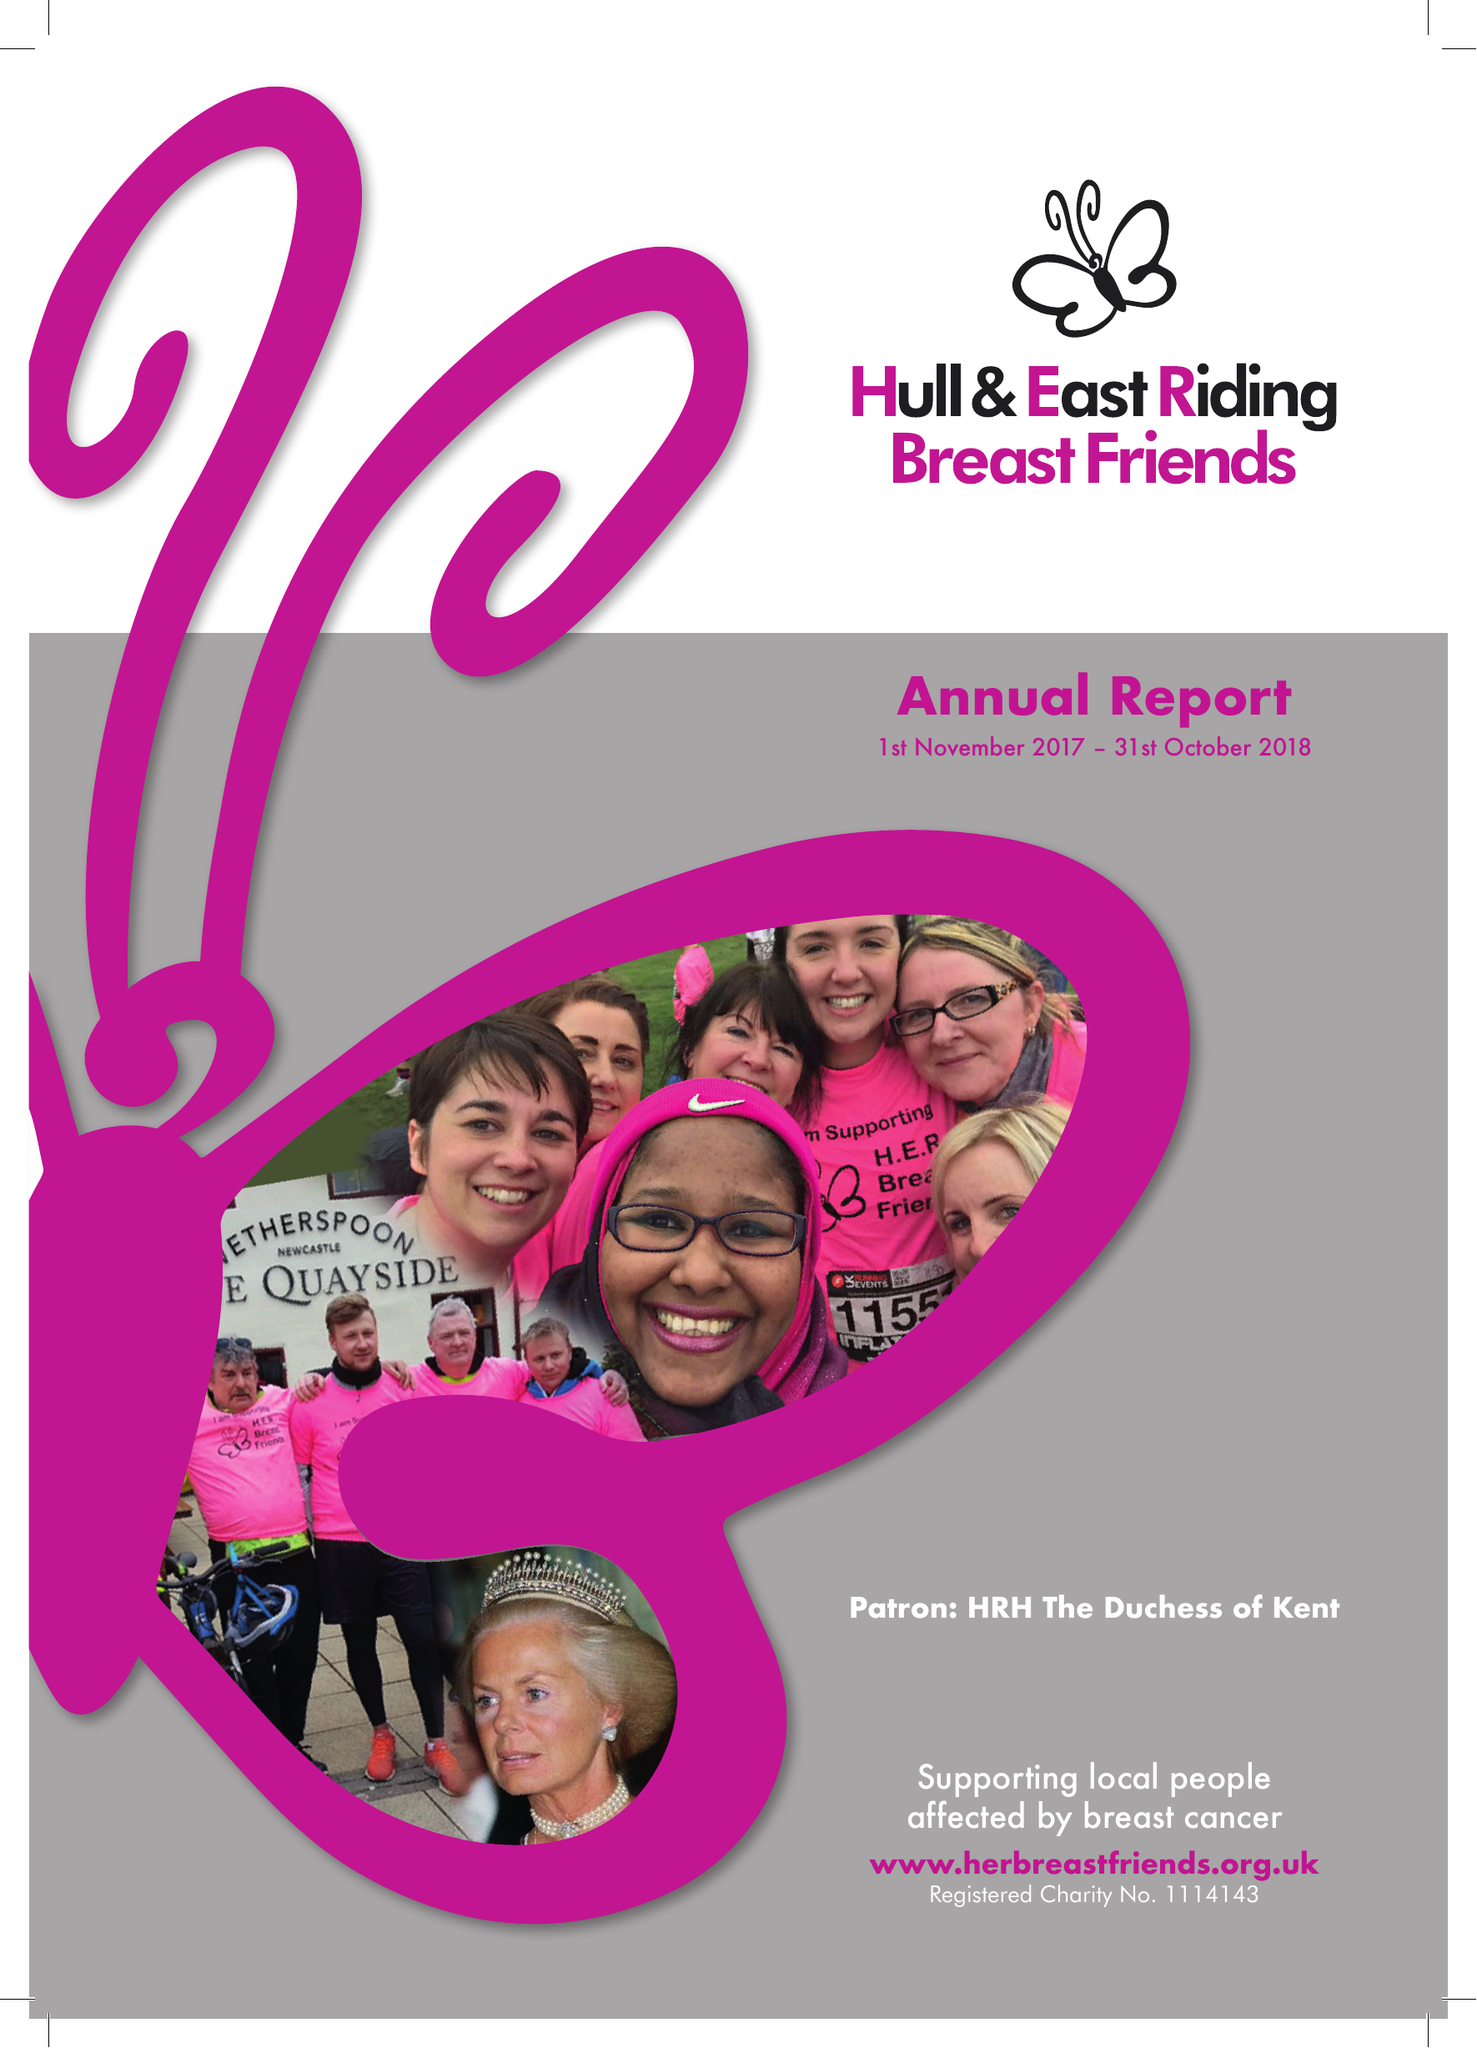What is the value for the address__postcode?
Answer the question using a single word or phrase. HU3 2RA 